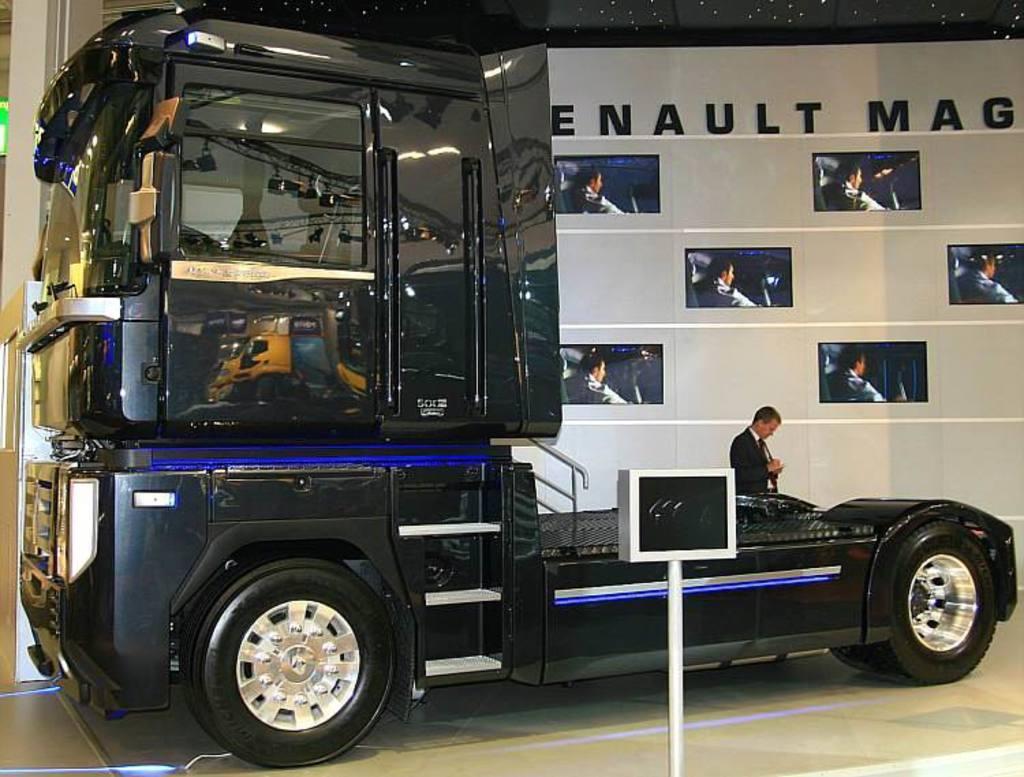In one or two sentences, can you explain what this image depicts? In this picture there is a black color vehicle and there is a person standing beside it and there are few televisions attached to the wall and there is something written above it in the background and there is an object on another side of a vehicle. 